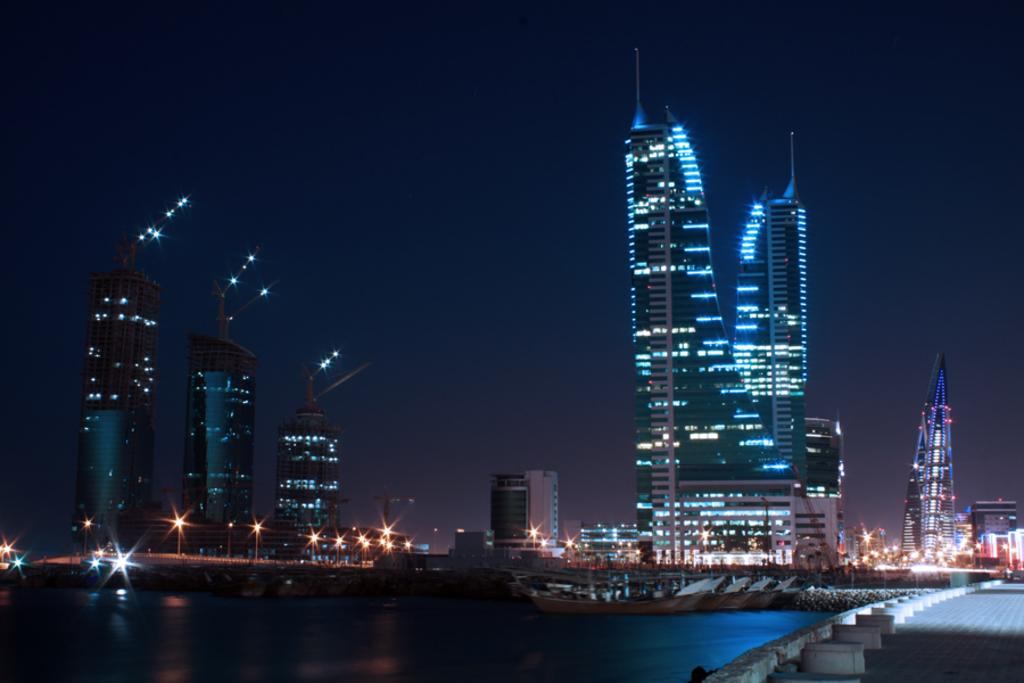What type of structures can be seen in the image? There are buildings in the image. What natural element is visible at the left bottom of the image? There is water visible at the left bottom of the image. What can be seen in the background of the image? There are lights in the background of the image. What is visible at the top of the image? The sky is visible at the top of the image. What type of crime is being committed in the image? There is no indication of any crime being committed in the image. What day of the week is it in the image? The day of the week cannot be determined from the image. 